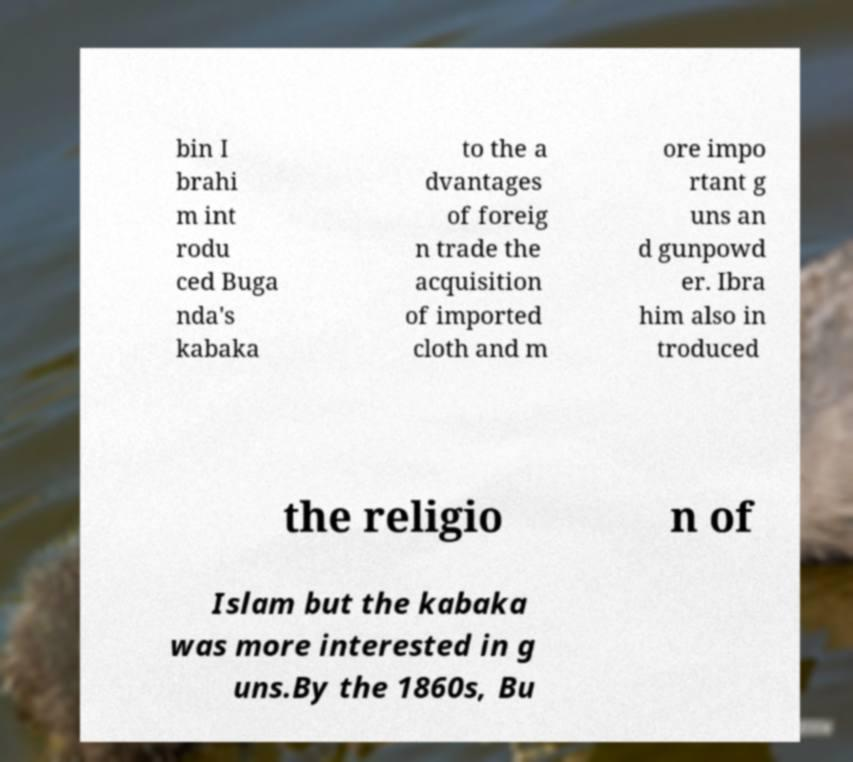What messages or text are displayed in this image? I need them in a readable, typed format. bin I brahi m int rodu ced Buga nda's kabaka to the a dvantages of foreig n trade the acquisition of imported cloth and m ore impo rtant g uns an d gunpowd er. Ibra him also in troduced the religio n of Islam but the kabaka was more interested in g uns.By the 1860s, Bu 